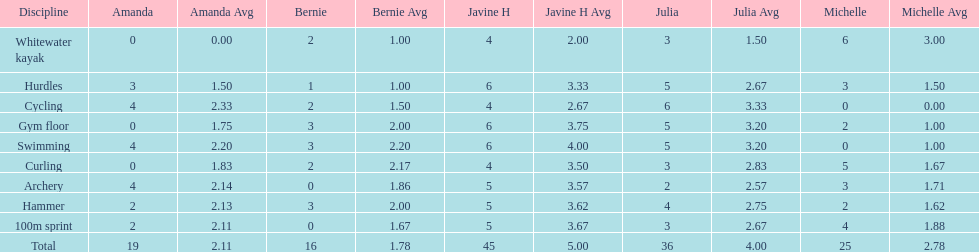What's the usual result for a 100m dash? 2.8. 